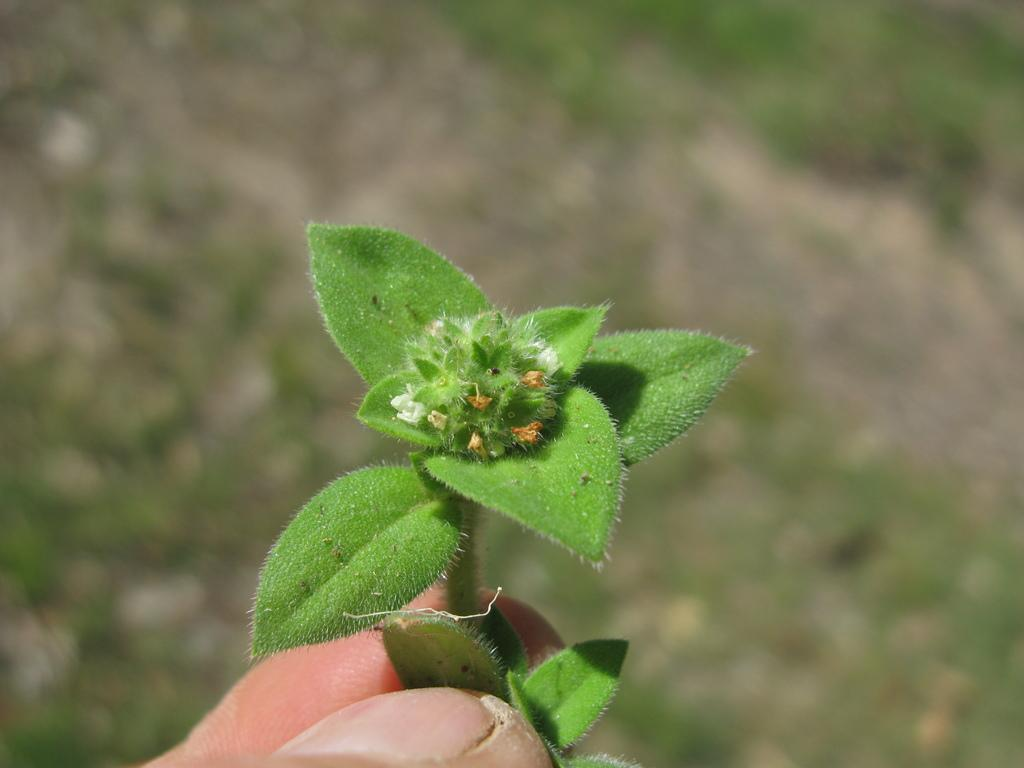What is the main subject of the image? The main subject of the image is a human hand. What is the hand holding in the image? The hand is holding a plant in the image. Can you describe the background of the image? The background of the image is blurred. What design is featured on the plant's leaves in the image? There is no information about the design on the plant's leaves in the image. 